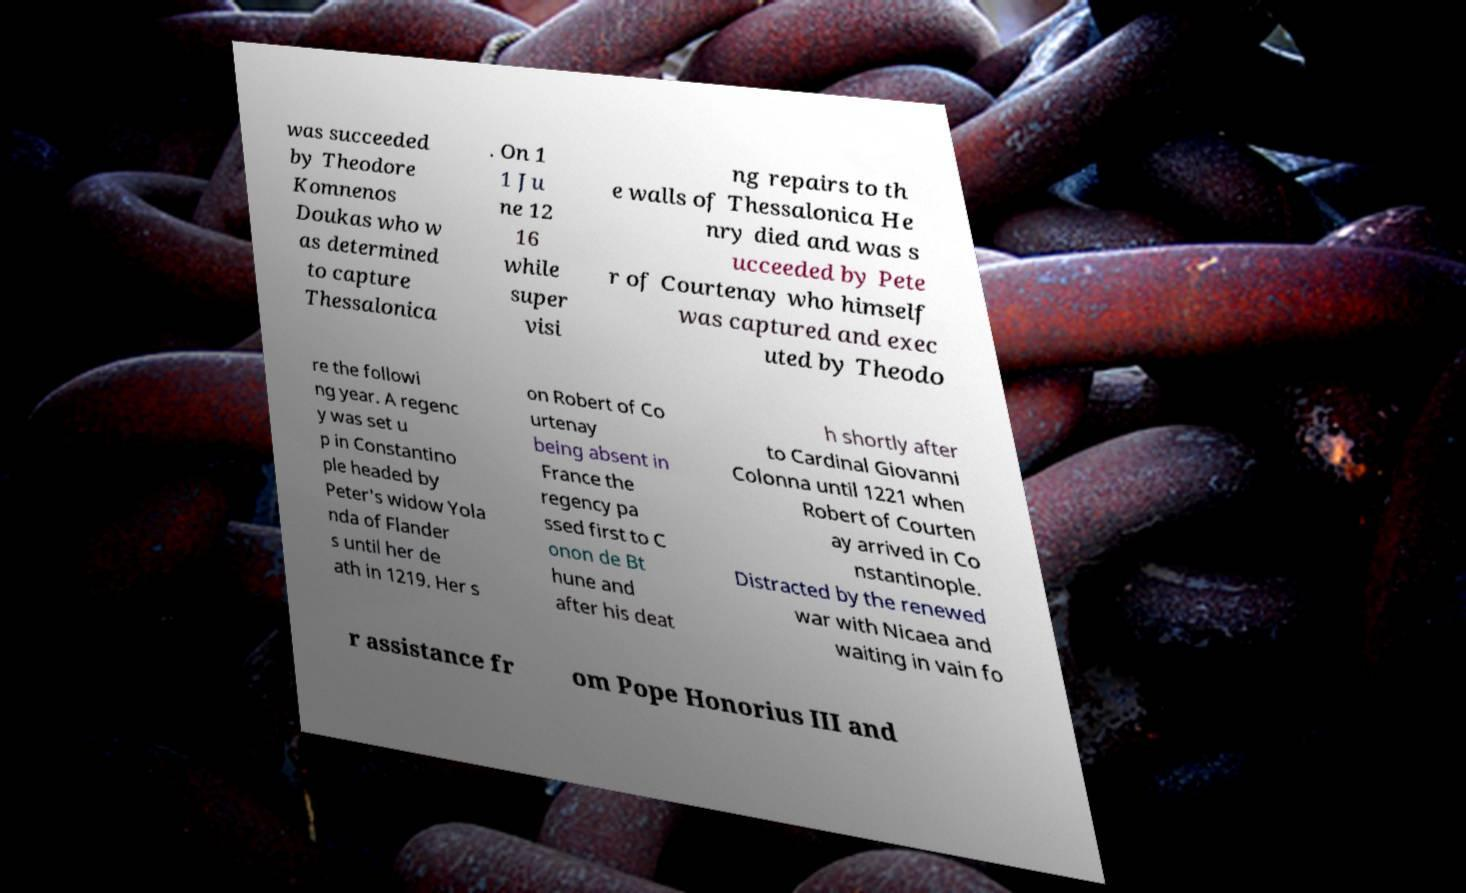There's text embedded in this image that I need extracted. Can you transcribe it verbatim? was succeeded by Theodore Komnenos Doukas who w as determined to capture Thessalonica . On 1 1 Ju ne 12 16 while super visi ng repairs to th e walls of Thessalonica He nry died and was s ucceeded by Pete r of Courtenay who himself was captured and exec uted by Theodo re the followi ng year. A regenc y was set u p in Constantino ple headed by Peter's widow Yola nda of Flander s until her de ath in 1219. Her s on Robert of Co urtenay being absent in France the regency pa ssed first to C onon de Bt hune and after his deat h shortly after to Cardinal Giovanni Colonna until 1221 when Robert of Courten ay arrived in Co nstantinople. Distracted by the renewed war with Nicaea and waiting in vain fo r assistance fr om Pope Honorius III and 